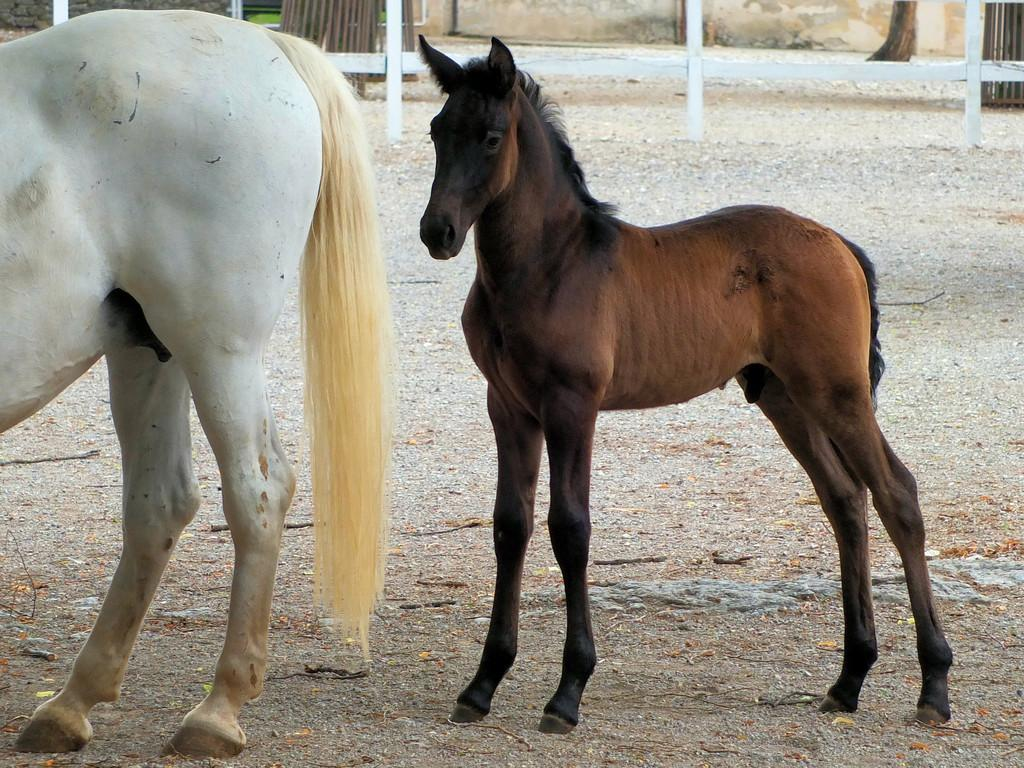How many horses are in the picture? There are two horses in the picture. What can be seen in the background of the picture? There is a wooden fence in the background of the picture. What type of gold jewelry is the horse wearing in the picture? There is no gold jewelry present on the horses in the picture. Can you describe the interaction between the two horses and their friend in the picture? There is no friend present in the picture, as it only features two horses and a wooden fence in the background. 